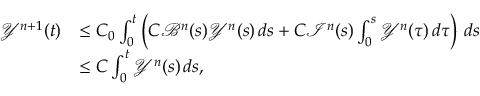<formula> <loc_0><loc_0><loc_500><loc_500>\begin{array} { r l } { \mathcal { Y } ^ { n + 1 } ( t ) } & { \leq C _ { 0 } \int _ { 0 } ^ { t } \left ( C \mathcal { B } ^ { n } ( s ) \mathcal { Y } ^ { n } ( s ) \, d s + C \mathcal { I } ^ { n } ( s ) \int _ { 0 } ^ { s } \mathcal { Y } ^ { n } ( \tau ) \, d \tau \right ) \, d s } \\ & { \leq C \int _ { 0 } ^ { t } \mathcal { Y } ^ { n } ( s ) \, d s , } \end{array}</formula> 